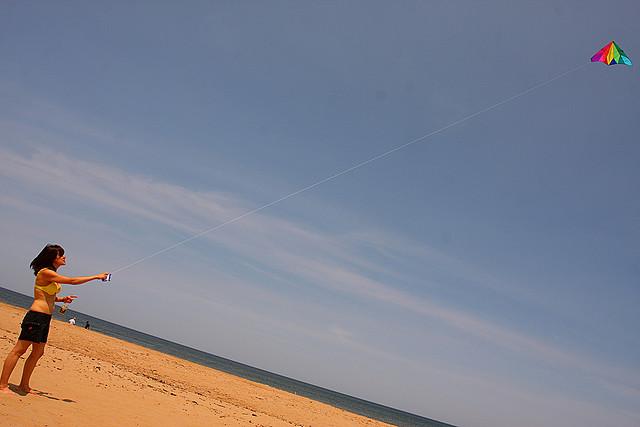What sport is this?
Be succinct. Kite flying. What is the woman doing?
Give a very brief answer. Flying kite. Is this kite difficult to fly?
Keep it brief. No. Is this a girl?
Write a very short answer. Yes. What is at the end of the string the woman is holding?
Keep it brief. Kite. Is the girl young?
Quick response, please. Yes. Is this person skiing?
Keep it brief. No. What is floating above the person?
Quick response, please. Kite. What sport is being done?
Give a very brief answer. Kite flying. What pattern is the this person's shorts?
Concise answer only. Solid. What is the girl wearing?
Keep it brief. Shorts and bikini top. 